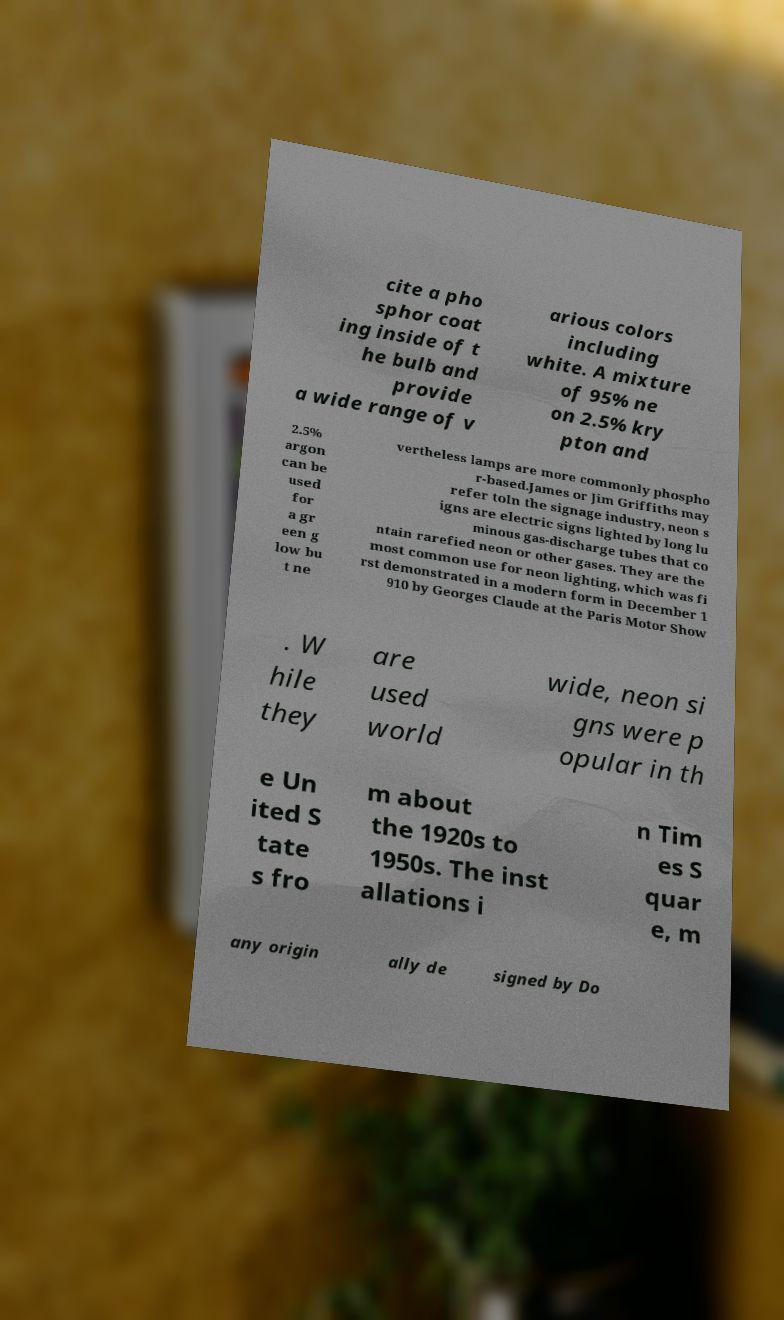Can you read and provide the text displayed in the image?This photo seems to have some interesting text. Can you extract and type it out for me? cite a pho sphor coat ing inside of t he bulb and provide a wide range of v arious colors including white. A mixture of 95% ne on 2.5% kry pton and 2.5% argon can be used for a gr een g low bu t ne vertheless lamps are more commonly phospho r-based.James or Jim Griffiths may refer toIn the signage industry, neon s igns are electric signs lighted by long lu minous gas-discharge tubes that co ntain rarefied neon or other gases. They are the most common use for neon lighting, which was fi rst demonstrated in a modern form in December 1 910 by Georges Claude at the Paris Motor Show . W hile they are used world wide, neon si gns were p opular in th e Un ited S tate s fro m about the 1920s to 1950s. The inst allations i n Tim es S quar e, m any origin ally de signed by Do 